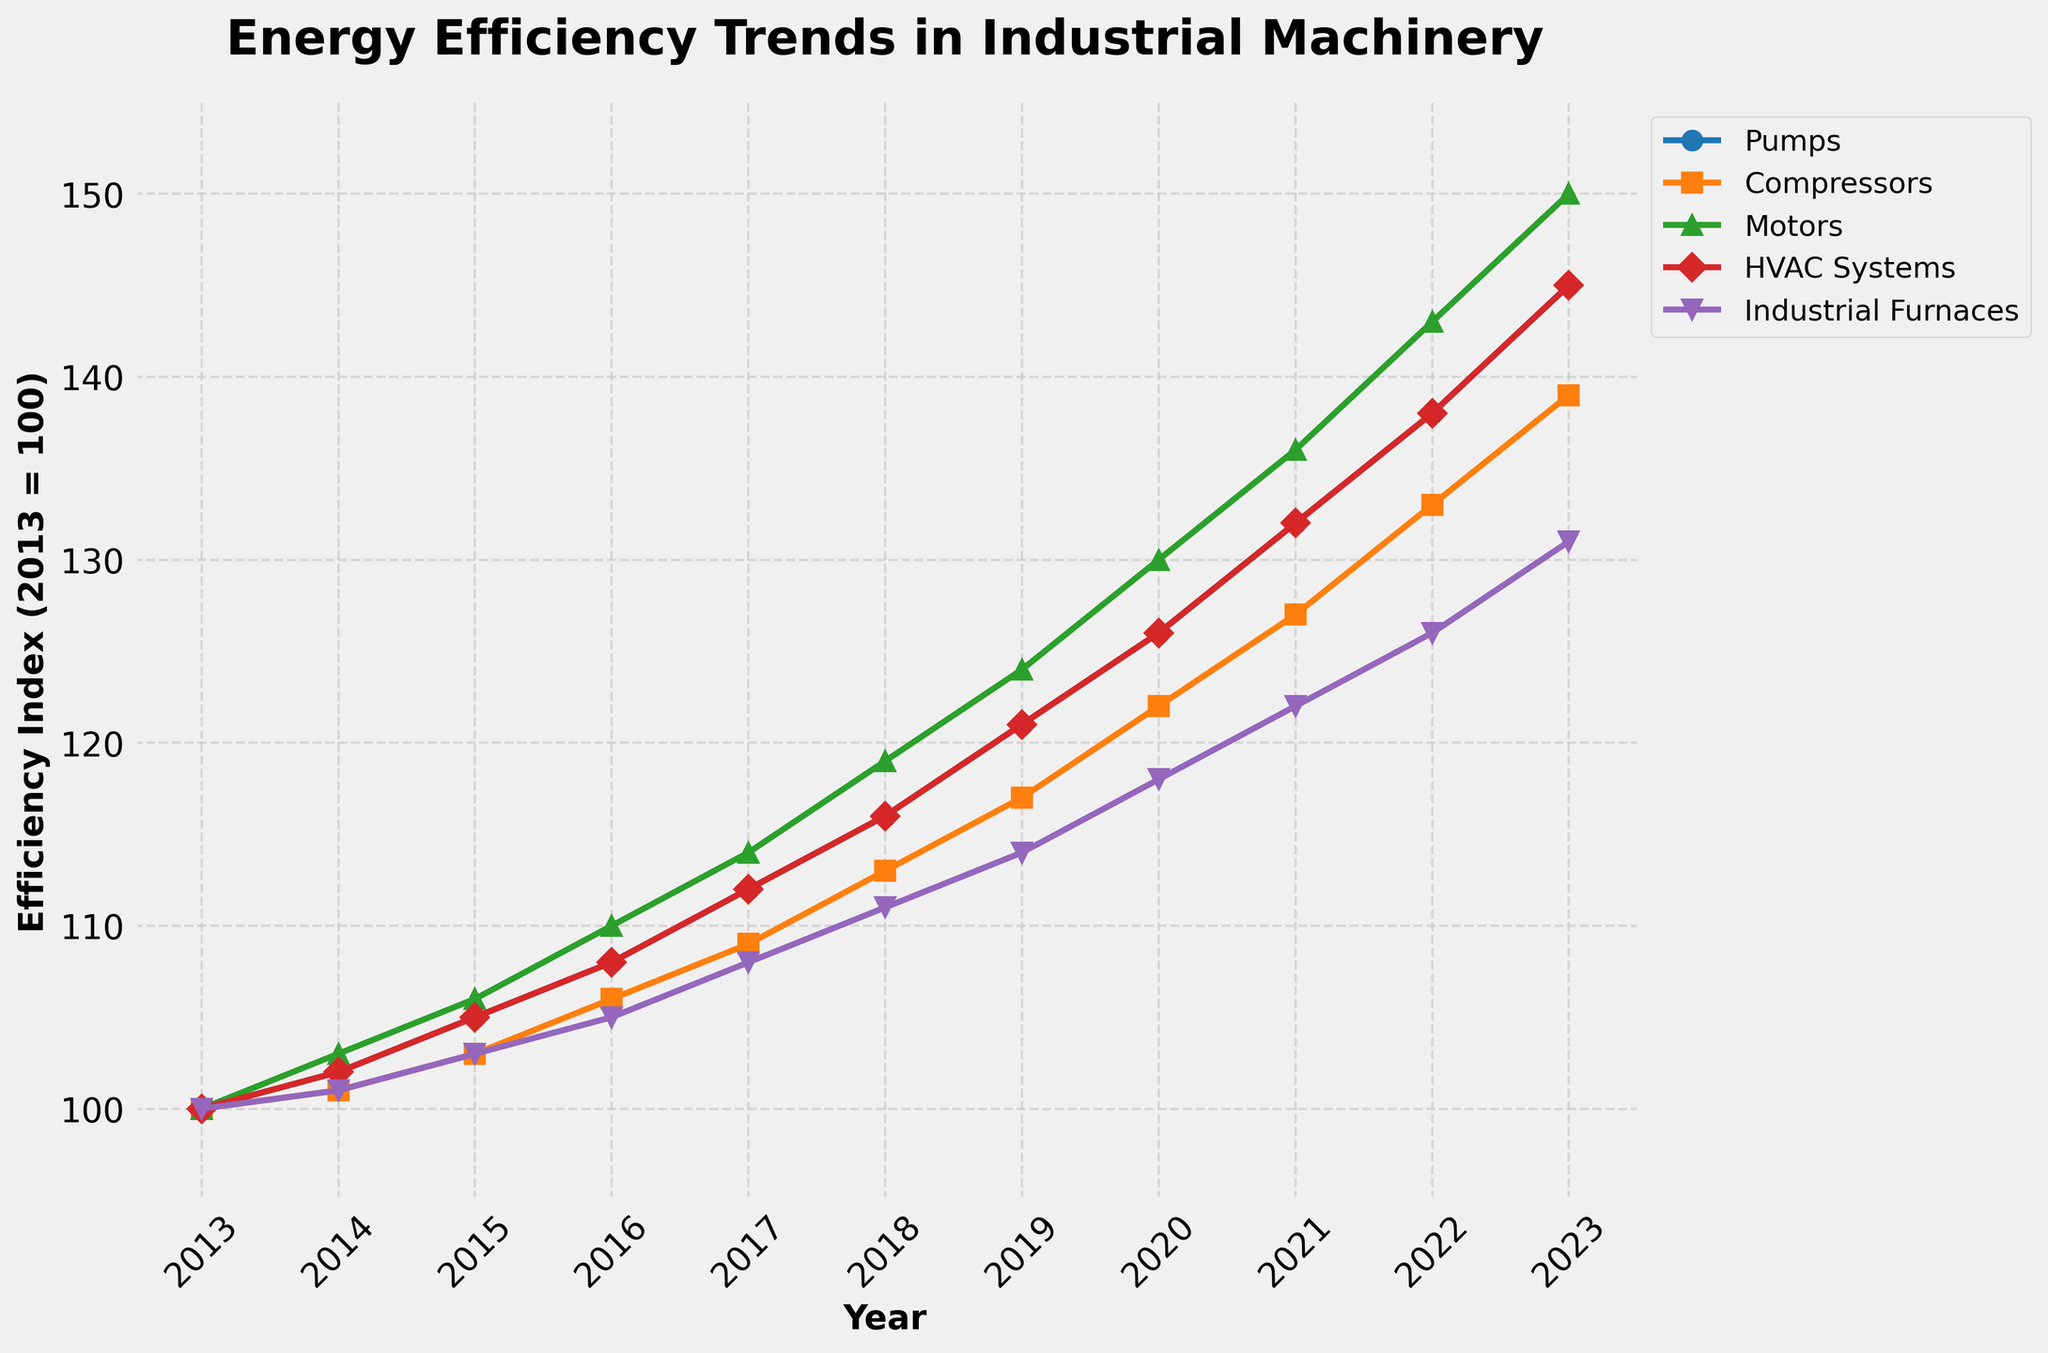What was the efficiency index of Motors in 2017? Look for the data point on the line representing Motors (usually identified by color and markers) at the year 2017.
Answer: 114 Which equipment type showed the most improvement in energy efficiency from 2013 to 2023? Calculate the difference in the efficiency index for each equipment type from 2013 to 2023 and compare the values to identify the largest change.
Answer: Pumps What is the average energy efficiency index for HVAC Systems over the last three years (2021-2023)? Find the values for HVAC Systems from 2021 to 2023, sum them up and divide by 3: (132 + 138 + 145) / 3.
Answer: 138.33 Between Compressors and Industrial Furnaces, which has a higher efficiency index in 2020, and by how much? Compare the values for Compressors and Industrial Furnaces in 2020: 122 for Compressors and 118 for Industrial Furnaces. Subtract the smaller value from the larger.
Answer: Compressors, by 4 In which year did Industrial Furnaces exceed the efficiency index of 120? Find the first year in which the Industrial Furnaces line crosses the horizontal level of 120.
Answer: 2021 By how much did the efficiency index for Pumps increase from 2015 to 2023? Subtract the efficiency index of Pumps in 2015 from that in 2023: 145 - 105.
Answer: 40 Which equipment type had the least variability in energy efficiency improvement over the decade? Observe the slope of each line and note the overall smoothness (least steep changes) across the years.
Answer: Industrial Furnaces Which equipment type had the steadiest increase in energy efficiency from 2016 to 2023? Observe the slopes of the lines from 2016 to 2023. The steadiest increase has the most consistent upward slope.
Answer: HVAC Systems How much higher was the efficiency index of Pumps compared to Compressors in 2023? Compare the efficiency indices for both equipment types in 2023 (Pumps: 145, Compressors: 139): 145 - 139.
Answer: 6 In what year did Motors reach an efficiency index of at least 130? Identify the first year the Motors line reaches or exceeds an index of 130.
Answer: 2021 